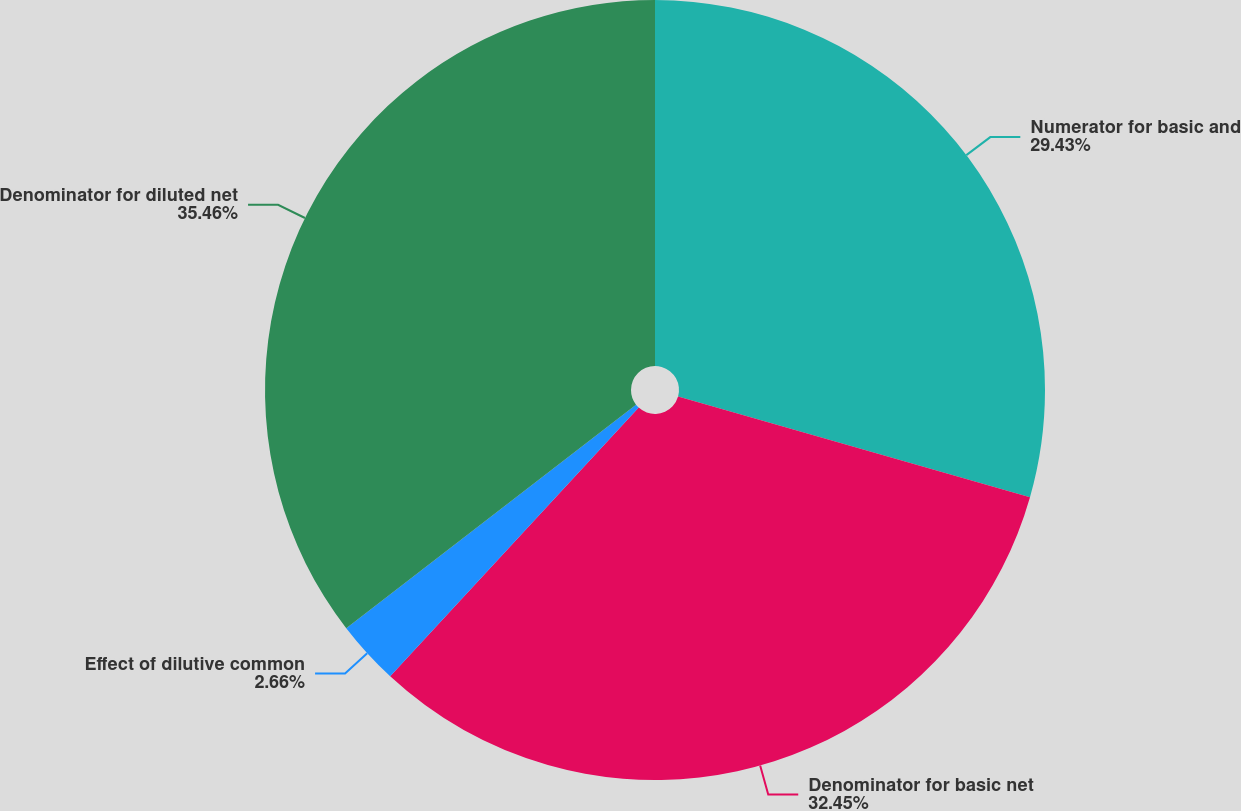Convert chart to OTSL. <chart><loc_0><loc_0><loc_500><loc_500><pie_chart><fcel>Numerator for basic and<fcel>Denominator for basic net<fcel>Effect of dilutive common<fcel>Denominator for diluted net<nl><fcel>29.43%<fcel>32.45%<fcel>2.66%<fcel>35.46%<nl></chart> 